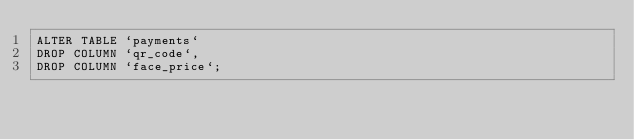<code> <loc_0><loc_0><loc_500><loc_500><_SQL_>ALTER TABLE `payments`
DROP COLUMN `qr_code`,
DROP COLUMN `face_price`;
</code> 